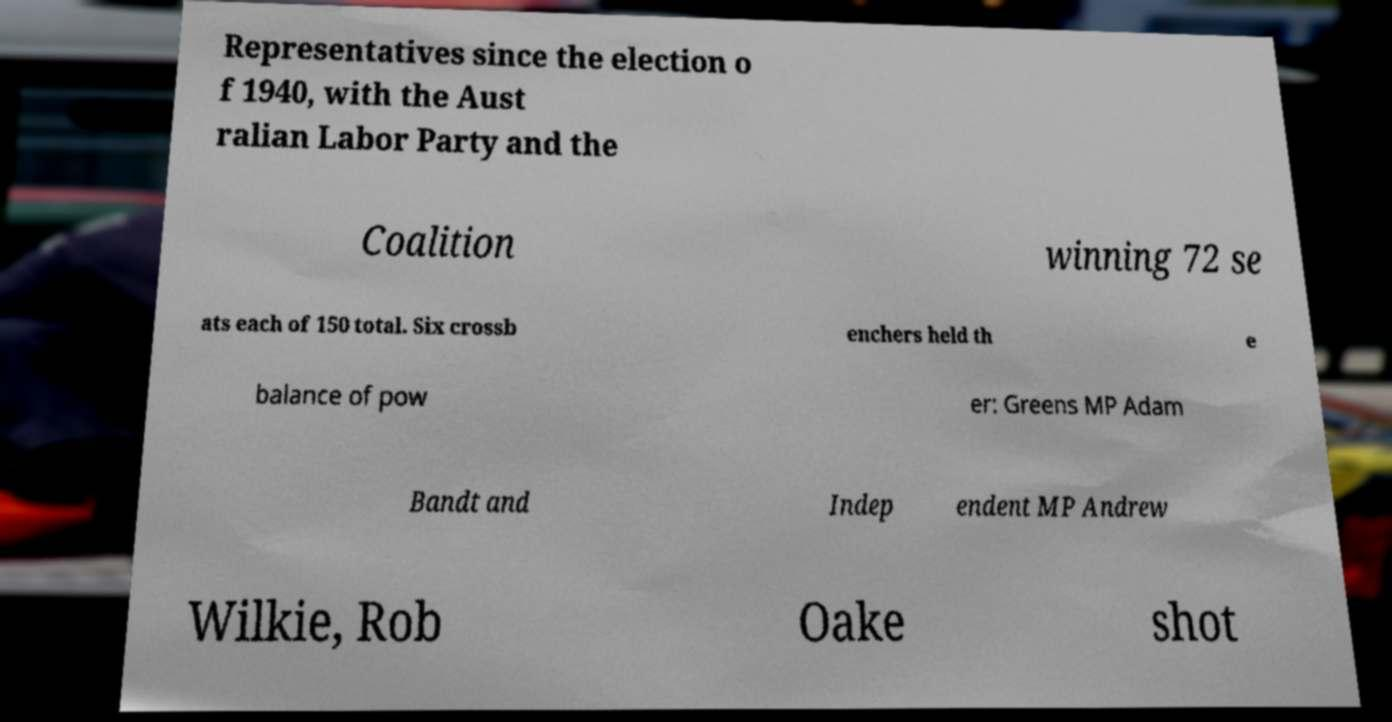There's text embedded in this image that I need extracted. Can you transcribe it verbatim? Representatives since the election o f 1940, with the Aust ralian Labor Party and the Coalition winning 72 se ats each of 150 total. Six crossb enchers held th e balance of pow er: Greens MP Adam Bandt and Indep endent MP Andrew Wilkie, Rob Oake shot 